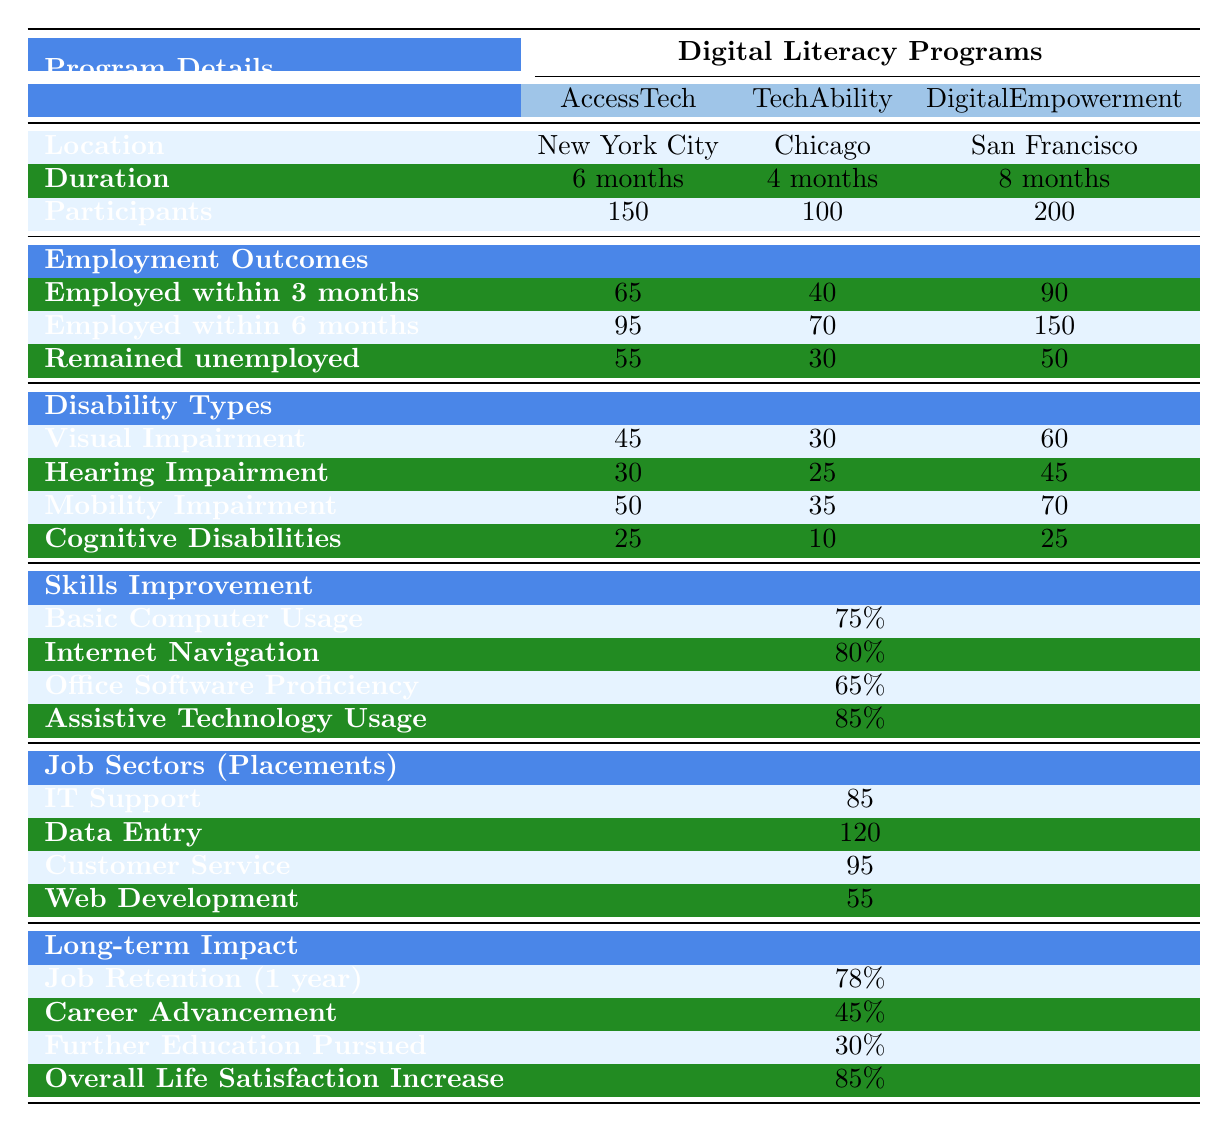What is the duration of the DigitalEmpowerment program? The table lists 'Duration' for each program. For DigitalEmpowerment, it states '8 months'.
Answer: 8 months How many participants were there in the AccessTech program? The table shows 'Participants' under the AccessTech program is '150'.
Answer: 150 Which program had the highest number of participants? By comparing the number of participants across all programs, DigitalEmpowerment has '200', while AccessTech has '150', and TechAbility has '100'. Thus, DigitalEmpowerment had the highest.
Answer: DigitalEmpowerment What percentage of participants were employed within 6 months in the TechAbility program? The table states that 'Employed within 6 months' for TechAbility is '70'.
Answer: 70 How many individuals with mobility impairment participated in the DigitalEmpowerment program? The 'Mobility Impairment' row under Disability Types for DigitalEmpowerment indicates '70'.
Answer: 70 Which program has the lowest percentage of individuals employed within 3 months? The percentages of employed individuals within 3 months are 65 for AccessTech, 40 for TechAbility, and 90 for DigitalEmpowerment. TechAbility has the lowest with 40.
Answer: TechAbility What is the average improvement in internet navigation skills across all programs? The table lists the average improvement in 'Internet Navigation' at 80%.
Answer: 80% What was the total number of participants across all three programs? Summing the participants: 150 (AccessTech) + 100 (TechAbility) + 200 (DigitalEmpowerment) equals 450.
Answer: 450 Which type of disability had the highest number of participants in the AccessTech program? In AccessTech, 'Mobility Impairment' has 50 participants, which is higher than the other types, as Visual Impairment has 45, Hearing Impairment has 30, and Cognitive Disabilities have 25.
Answer: Mobility Impairment What is the long-term impact percentage for overall life satisfaction increase? The table shows that 'Overall Life Satisfaction Increase' has a percentage of '85%'.
Answer: 85% In which job sector was the highest number of placements achieved? The job sector with the highest placements is 'Data Entry' with 120 placements, when compared to IT Support (85), Customer Service (95), and Web Development (55).
Answer: Data Entry Calculate the percentage of participants who remained unemployed after the AccessTech program. There were 150 participants in AccessTech, with 55 remaining unemployed. Thus, the calculation is (55/150) * 100 = 36.67%.
Answer: 36.67% Did the DigitalEmpowerment program have a higher employment outcome over 6 months compared to TechAbility? DigitalEmpowerment had 150 employed within 6 months and TechAbility had 70. Therefore, it had a higher outcome.
Answer: Yes What is the difference in the number of employed individuals between AccessTech and DigitalEmpowerment within 3 months? AccessTech had 65 employed, and DigitalEmpowerment had 90 employed within 3 months. The difference is 90 - 65 = 25.
Answer: 25 What percentage of participants pursued further education after these programs? The table indicates that the percentage of participants who pursued further education is 30%.
Answer: 30% 